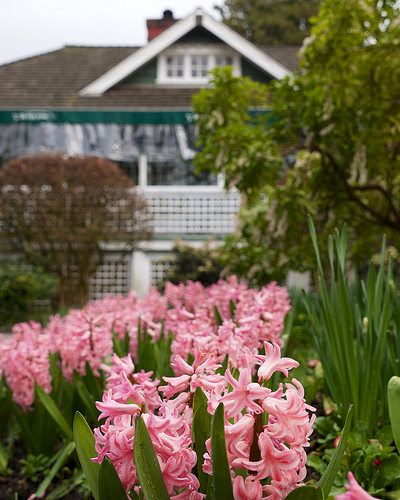<image>
Can you confirm if the tree is on the flower? No. The tree is not positioned on the flower. They may be near each other, but the tree is not supported by or resting on top of the flower. 